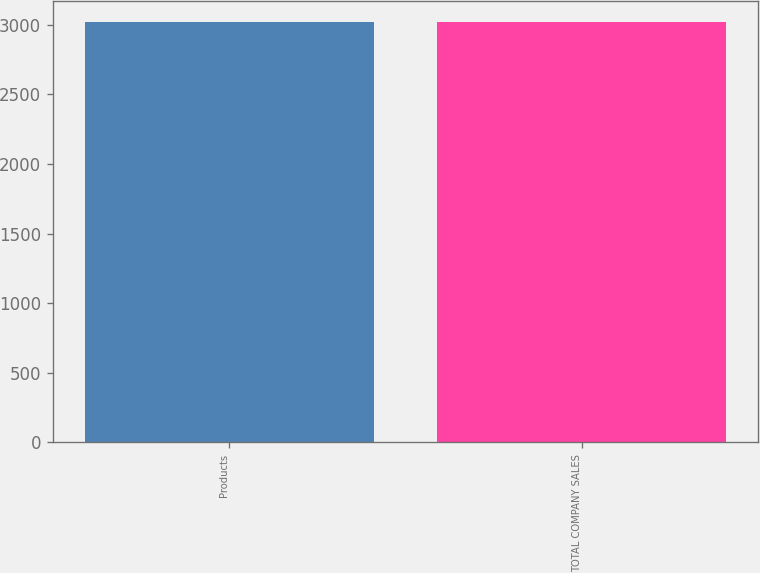Convert chart. <chart><loc_0><loc_0><loc_500><loc_500><bar_chart><fcel>Products<fcel>TOTAL COMPANY SALES<nl><fcel>3021.9<fcel>3022<nl></chart> 